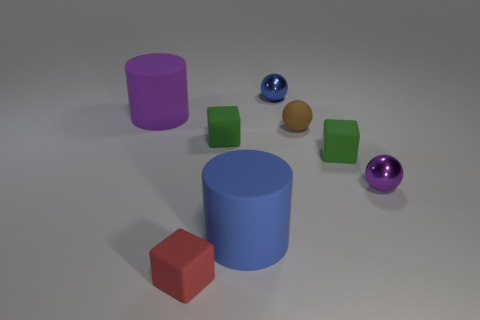How many objects are either blue objects that are behind the purple cylinder or tiny rubber cubes that are right of the big blue rubber cylinder?
Your answer should be compact. 2. The blue metallic thing that is the same size as the red rubber cube is what shape?
Your response must be concise. Sphere. Is there a purple shiny thing that has the same shape as the blue metallic thing?
Ensure brevity in your answer.  Yes. Are there fewer brown spheres than small green blocks?
Give a very brief answer. Yes. Is the size of the purple object that is on the right side of the large purple rubber cylinder the same as the shiny thing that is behind the small purple metallic ball?
Make the answer very short. Yes. How many objects are small brown rubber things or cylinders?
Give a very brief answer. 3. How big is the cylinder that is in front of the purple metallic sphere?
Make the answer very short. Large. There is a purple thing on the right side of the large matte thing that is to the left of the red matte object; how many tiny green objects are in front of it?
Your response must be concise. 0. How many purple things are to the right of the red block and left of the purple ball?
Your answer should be very brief. 0. What is the shape of the small green matte thing that is left of the brown rubber sphere?
Make the answer very short. Cube. 